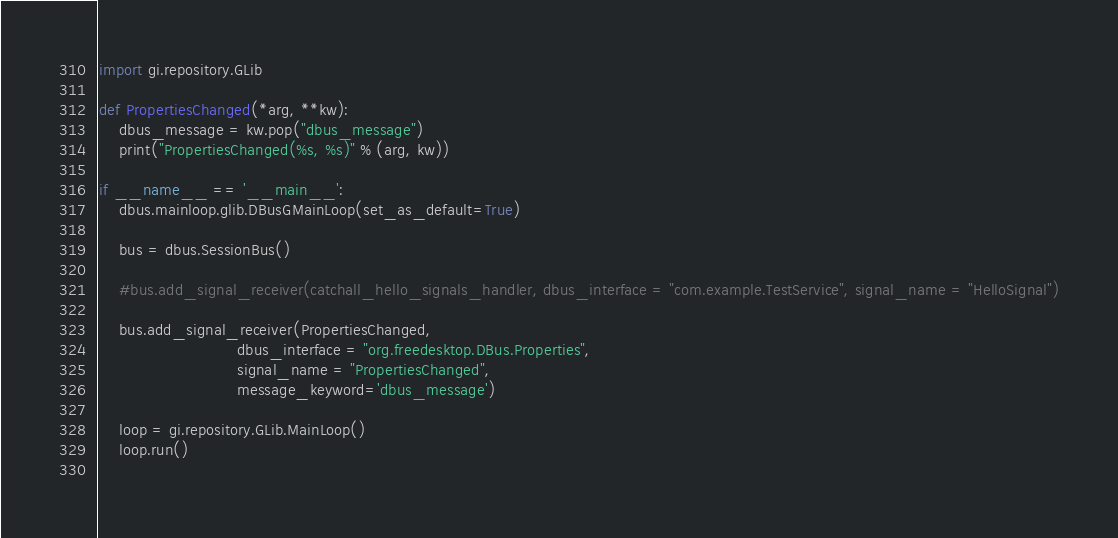Convert code to text. <code><loc_0><loc_0><loc_500><loc_500><_Python_>import gi.repository.GLib

def PropertiesChanged(*arg, **kw):
    dbus_message = kw.pop("dbus_message")
    print("PropertiesChanged(%s, %s)" % (arg, kw))

if __name__ == '__main__':
    dbus.mainloop.glib.DBusGMainLoop(set_as_default=True)

    bus = dbus.SessionBus()

    #bus.add_signal_receiver(catchall_hello_signals_handler, dbus_interface = "com.example.TestService", signal_name = "HelloSignal")

    bus.add_signal_receiver(PropertiesChanged,
                            dbus_interface = "org.freedesktop.DBus.Properties",
                            signal_name = "PropertiesChanged",
                            message_keyword='dbus_message')

    loop = gi.repository.GLib.MainLoop()
    loop.run()
    
</code> 